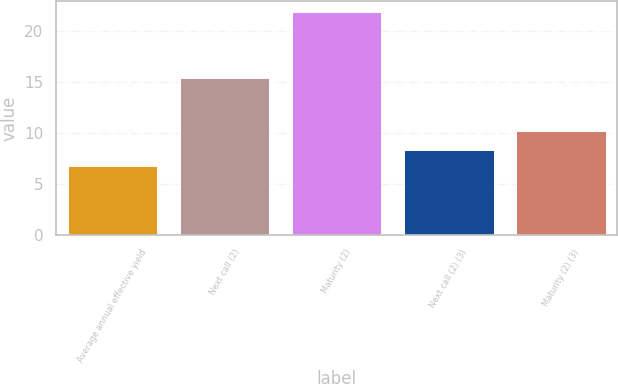Convert chart to OTSL. <chart><loc_0><loc_0><loc_500><loc_500><bar_chart><fcel>Average annual effective yield<fcel>Next call (2)<fcel>Maturity (2)<fcel>Next call (2) (3)<fcel>Maturity (2) (3)<nl><fcel>6.8<fcel>15.4<fcel>21.9<fcel>8.31<fcel>10.2<nl></chart> 